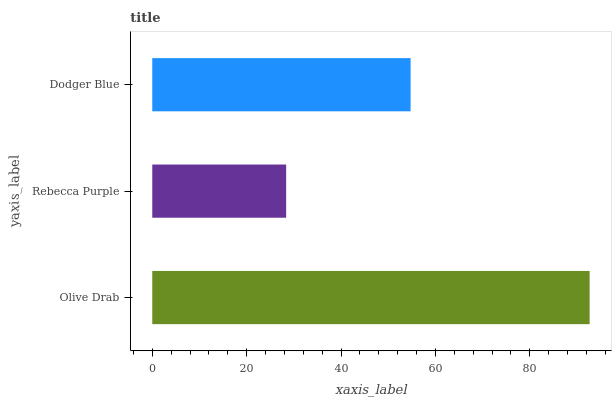Is Rebecca Purple the minimum?
Answer yes or no. Yes. Is Olive Drab the maximum?
Answer yes or no. Yes. Is Dodger Blue the minimum?
Answer yes or no. No. Is Dodger Blue the maximum?
Answer yes or no. No. Is Dodger Blue greater than Rebecca Purple?
Answer yes or no. Yes. Is Rebecca Purple less than Dodger Blue?
Answer yes or no. Yes. Is Rebecca Purple greater than Dodger Blue?
Answer yes or no. No. Is Dodger Blue less than Rebecca Purple?
Answer yes or no. No. Is Dodger Blue the high median?
Answer yes or no. Yes. Is Dodger Blue the low median?
Answer yes or no. Yes. Is Olive Drab the high median?
Answer yes or no. No. Is Rebecca Purple the low median?
Answer yes or no. No. 